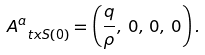<formula> <loc_0><loc_0><loc_500><loc_500>A _ { \ t x { S } ( 0 ) } ^ { a } = \left ( \frac { q } { \rho } , \, 0 , \, 0 , \, 0 \right ) .</formula> 